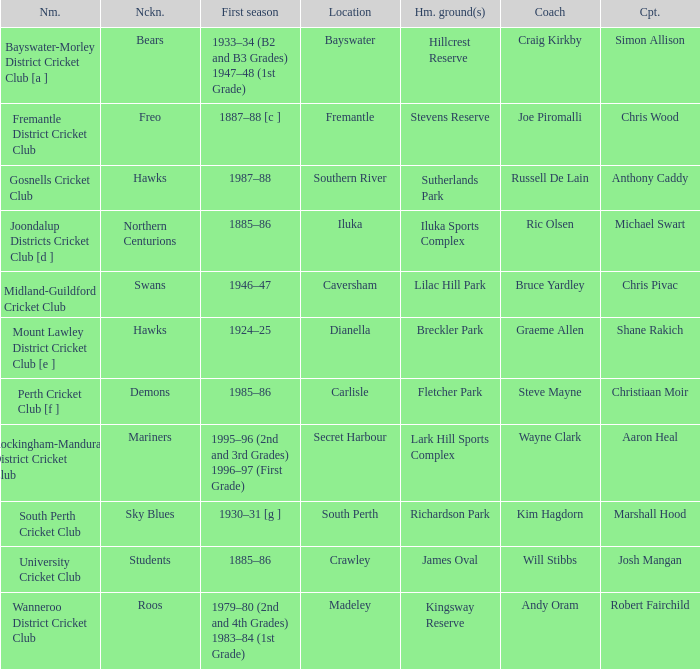For location Caversham, what is the name of the captain? Chris Pivac. Can you parse all the data within this table? {'header': ['Nm.', 'Nckn.', 'First season', 'Location', 'Hm. ground(s)', 'Coach', 'Cpt.'], 'rows': [['Bayswater-Morley District Cricket Club [a ]', 'Bears', '1933–34 (B2 and B3 Grades) 1947–48 (1st Grade)', 'Bayswater', 'Hillcrest Reserve', 'Craig Kirkby', 'Simon Allison'], ['Fremantle District Cricket Club', 'Freo', '1887–88 [c ]', 'Fremantle', 'Stevens Reserve', 'Joe Piromalli', 'Chris Wood'], ['Gosnells Cricket Club', 'Hawks', '1987–88', 'Southern River', 'Sutherlands Park', 'Russell De Lain', 'Anthony Caddy'], ['Joondalup Districts Cricket Club [d ]', 'Northern Centurions', '1885–86', 'Iluka', 'Iluka Sports Complex', 'Ric Olsen', 'Michael Swart'], ['Midland-Guildford Cricket Club', 'Swans', '1946–47', 'Caversham', 'Lilac Hill Park', 'Bruce Yardley', 'Chris Pivac'], ['Mount Lawley District Cricket Club [e ]', 'Hawks', '1924–25', 'Dianella', 'Breckler Park', 'Graeme Allen', 'Shane Rakich'], ['Perth Cricket Club [f ]', 'Demons', '1985–86', 'Carlisle', 'Fletcher Park', 'Steve Mayne', 'Christiaan Moir'], ['Rockingham-Mandurah District Cricket Club', 'Mariners', '1995–96 (2nd and 3rd Grades) 1996–97 (First Grade)', 'Secret Harbour', 'Lark Hill Sports Complex', 'Wayne Clark', 'Aaron Heal'], ['South Perth Cricket Club', 'Sky Blues', '1930–31 [g ]', 'South Perth', 'Richardson Park', 'Kim Hagdorn', 'Marshall Hood'], ['University Cricket Club', 'Students', '1885–86', 'Crawley', 'James Oval', 'Will Stibbs', 'Josh Mangan'], ['Wanneroo District Cricket Club', 'Roos', '1979–80 (2nd and 4th Grades) 1983–84 (1st Grade)', 'Madeley', 'Kingsway Reserve', 'Andy Oram', 'Robert Fairchild']]} 